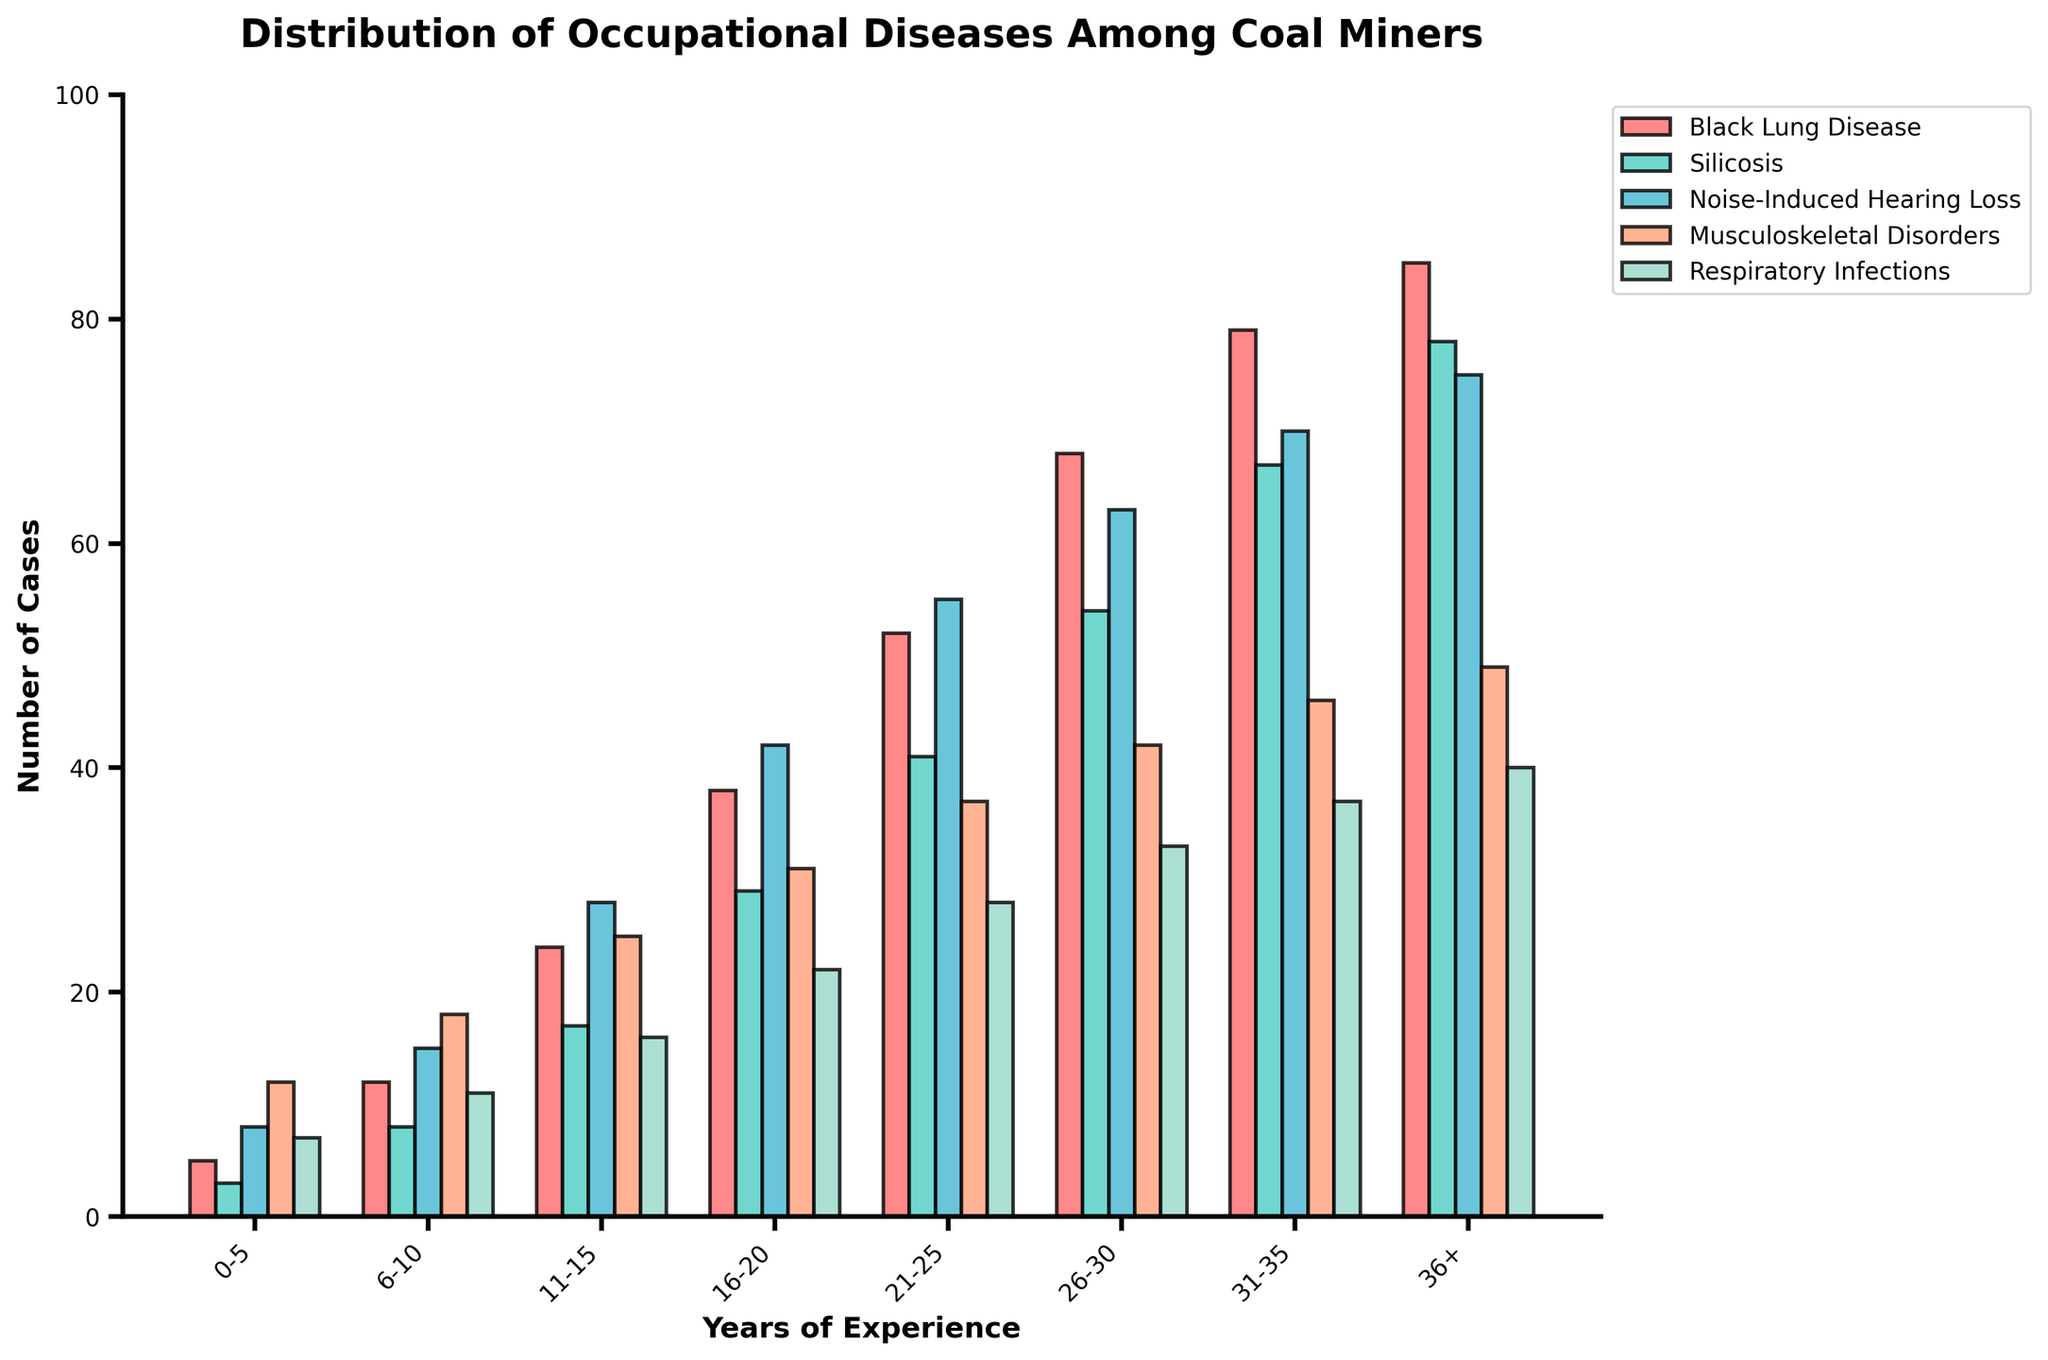What disease has the highest number of cases for miners with 16-20 years of experience? Look at the bars corresponding to 16-20 years of experience and identify the one with the highest value. Black Lung Disease has 38 cases, Silicosis has 29, Noise-Induced Hearing Loss has 42, Musculoskeletal Disorders has 31, and Respiratory Infections has 22.
Answer: Noise-Induced Hearing Loss What is the total number of Musculoskeletal Disorder cases across all years of experience? Sum the number of Musculoskeletal Disorders cases listed for each experience range. Add up 12 + 18 + 25 + 31 + 37 + 42 + 46 + 49.
Answer: 260 Which disease has the lowest number of cases for miners with 31-35 years of experience? Look at the bars for 31-35 years of experience and identify the one with the lowest value. Black Lung Disease has 79 cases, Silicosis has 67, Noise-Induced Hearing Loss has 70, Musculoskeletal Disorders has 46, and Respiratory Infections has 37.
Answer: Respiratory Infections Compare the number of Silicosis cases between miners with 0-5 years of experience and those with 11-15 years of experience. Look at the bars for Silicosis in both experience ranges. For 0-5 years, there are 3 cases. For 11-15 years, there are 17 cases. Subtract the smaller number from the larger one (17 - 3).
Answer: 14 How many more cases of Black Lung Disease are there for miners with 26-30 years of experience compared to those with 11-15 years of experience? Look at the bars for Black Lung Disease in both experience ranges. For 26-30 years, there are 68 cases. For 11-15 years, there are 24 cases. Subtract the smaller number from the larger one (68 - 24).
Answer: 44 What is the average number of Noise-Induced Hearing Loss cases for miners with varying years of experience? Sum the number of Noise-Induced Hearing Loss cases (8 + 15 + 28 + 42 + 55 + 63 + 70 + 75) and divide by the number of experience ranges (8).
Answer: 44.5 Which disease shows a consistent increase in cases as the years of experience increase? Observe the trend of each disease's bars across increasing experience ranges. Black Lung Disease shows an increase from 5 to 85 cases, and Silicosis shows an increase from 3 to 78 cases.
Answer: Black Lung Disease, Silicosis For miners with more than 36 years of experience, which disease has the second-highest number of cases? Look at the bars for miners with more than 36 years of experience and identify the second-highest value. Black Lung Disease has 85 cases, Silicosis has 78, Noise-Induced Hearing Loss has 75, Musculoskeletal Disorders have 49, and Respiratory Infections have 40.
Answer: Silicosis What is the difference in the total number of cases between Black Lung Disease and Respiratory Infections for miners with 21-25 years of experience? Look at the bars for 21-25 years of experience. Black Lung Disease has 52 cases, and Respiratory Infections have 28 cases. Subtract the number of Respiratory Infections cases from Black Lung Disease cases (52 - 28).
Answer: 24 